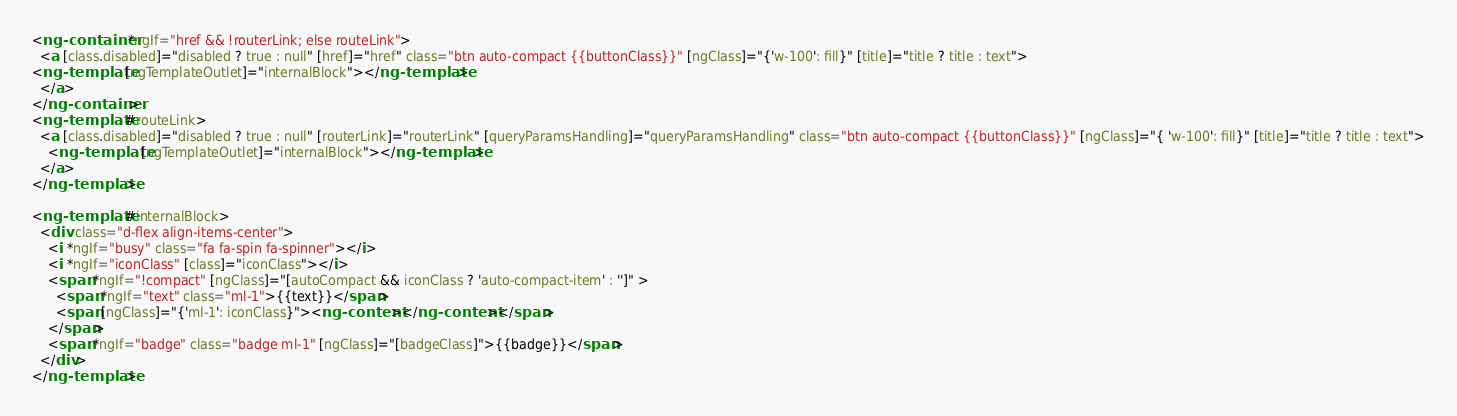Convert code to text. <code><loc_0><loc_0><loc_500><loc_500><_HTML_><ng-container *ngIf="href && !routerLink; else routeLink">
  <a [class.disabled]="disabled ? true : null" [href]="href" class="btn auto-compact {{buttonClass}}" [ngClass]="{'w-100': fill}" [title]="title ? title : text">
<ng-template [ngTemplateOutlet]="internalBlock"></ng-template>
  </a>
</ng-container>
<ng-template #routeLink>
  <a [class.disabled]="disabled ? true : null" [routerLink]="routerLink" [queryParamsHandling]="queryParamsHandling" class="btn auto-compact {{buttonClass}}" [ngClass]="{ 'w-100': fill}" [title]="title ? title : text">
    <ng-template [ngTemplateOutlet]="internalBlock"></ng-template>
  </a>
</ng-template>

<ng-template #internalBlock>
  <div class="d-flex align-items-center">
    <i *ngIf="busy" class="fa fa-spin fa-spinner"></i>
    <i *ngIf="iconClass" [class]="iconClass"></i>
    <span *ngIf="!compact" [ngClass]="[autoCompact && iconClass ? 'auto-compact-item' : '']" >
      <span *ngIf="text" class="ml-1">{{text}}</span>
      <span [ngClass]="{'ml-1': iconClass}"><ng-content></ng-content></span>
    </span>
    <span *ngIf="badge" class="badge ml-1" [ngClass]="[badgeClass]">{{badge}}</span>
  </div>
</ng-template></code> 